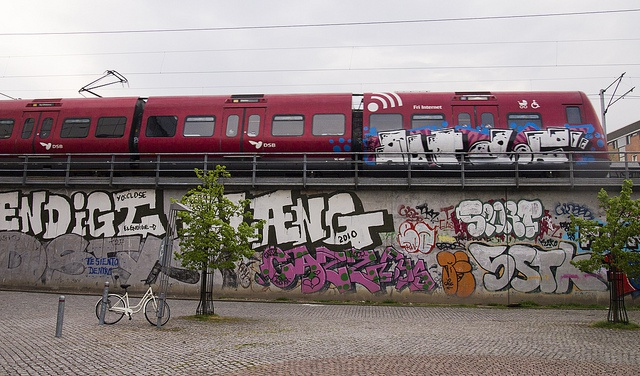Describe the objects in this image and their specific colors. I can see train in white, black, maroon, brown, and gray tones and bicycle in white, gray, black, and darkgray tones in this image. 